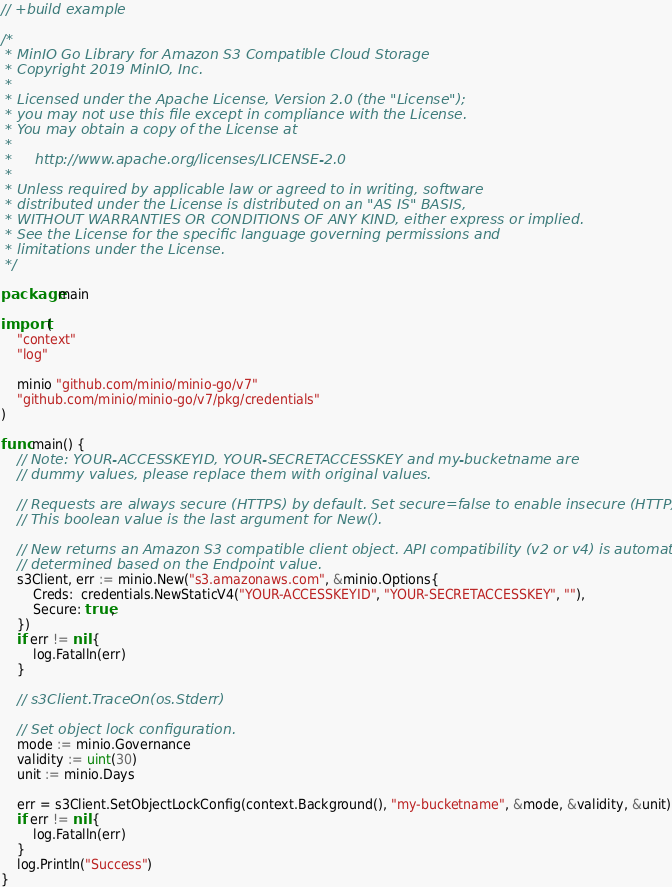Convert code to text. <code><loc_0><loc_0><loc_500><loc_500><_Go_>// +build example

/*
 * MinIO Go Library for Amazon S3 Compatible Cloud Storage
 * Copyright 2019 MinIO, Inc.
 *
 * Licensed under the Apache License, Version 2.0 (the "License");
 * you may not use this file except in compliance with the License.
 * You may obtain a copy of the License at
 *
 *     http://www.apache.org/licenses/LICENSE-2.0
 *
 * Unless required by applicable law or agreed to in writing, software
 * distributed under the License is distributed on an "AS IS" BASIS,
 * WITHOUT WARRANTIES OR CONDITIONS OF ANY KIND, either express or implied.
 * See the License for the specific language governing permissions and
 * limitations under the License.
 */

package main

import (
	"context"
	"log"

	minio "github.com/minio/minio-go/v7"
	"github.com/minio/minio-go/v7/pkg/credentials"
)

func main() {
	// Note: YOUR-ACCESSKEYID, YOUR-SECRETACCESSKEY and my-bucketname are
	// dummy values, please replace them with original values.

	// Requests are always secure (HTTPS) by default. Set secure=false to enable insecure (HTTP) access.
	// This boolean value is the last argument for New().

	// New returns an Amazon S3 compatible client object. API compatibility (v2 or v4) is automatically
	// determined based on the Endpoint value.
	s3Client, err := minio.New("s3.amazonaws.com", &minio.Options{
		Creds:  credentials.NewStaticV4("YOUR-ACCESSKEYID", "YOUR-SECRETACCESSKEY", ""),
		Secure: true,
	})
	if err != nil {
		log.Fatalln(err)
	}

	// s3Client.TraceOn(os.Stderr)

	// Set object lock configuration.
	mode := minio.Governance
	validity := uint(30)
	unit := minio.Days

	err = s3Client.SetObjectLockConfig(context.Background(), "my-bucketname", &mode, &validity, &unit)
	if err != nil {
		log.Fatalln(err)
	}
	log.Println("Success")
}
</code> 